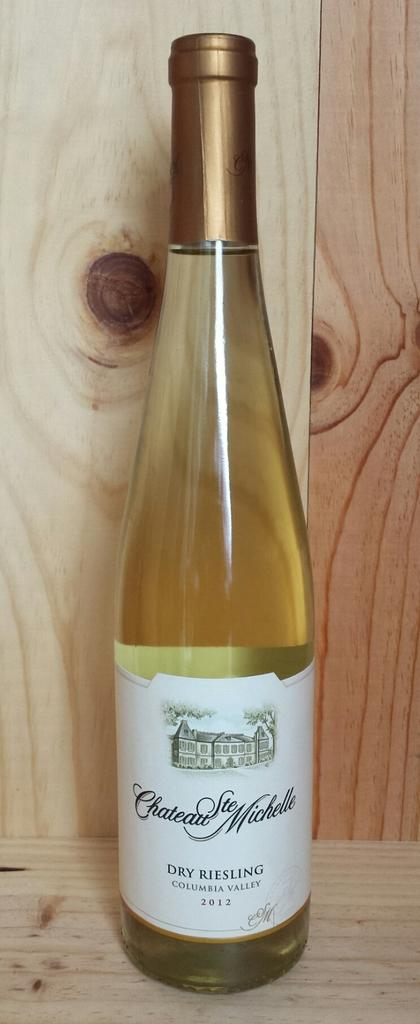Provide a one-sentence caption for the provided image. Bottle of alcohol with a label that says "Dry Riesling" on it. 